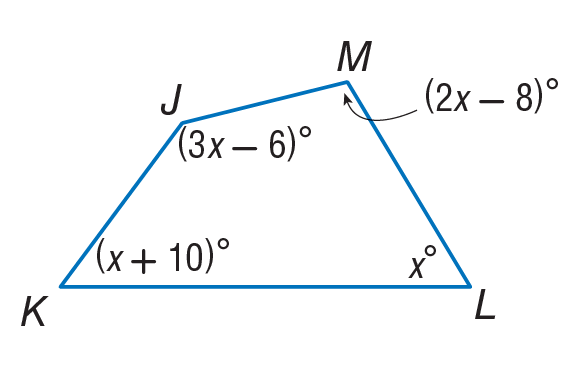Answer the mathemtical geometry problem and directly provide the correct option letter.
Question: Find m \angle M.
Choices: A: 62 B: 71 C: 96 D: 106 C 